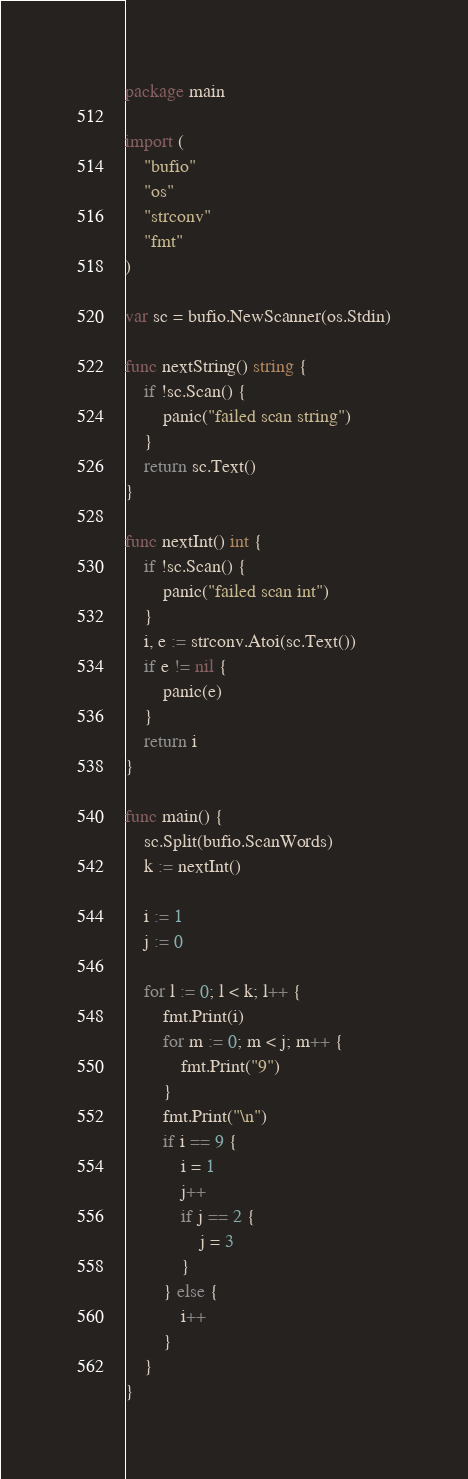<code> <loc_0><loc_0><loc_500><loc_500><_Go_>package main

import (
	"bufio"
	"os"
	"strconv"
	"fmt"
)

var sc = bufio.NewScanner(os.Stdin)

func nextString() string {
	if !sc.Scan() {
		panic("failed scan string")
	}
	return sc.Text()
}

func nextInt() int {
	if !sc.Scan() {
		panic("failed scan int")
	}
	i, e := strconv.Atoi(sc.Text())
	if e != nil {
		panic(e)
	}
	return i
}

func main() {
	sc.Split(bufio.ScanWords)
	k := nextInt()

	i := 1
	j := 0

	for l := 0; l < k; l++ {
		fmt.Print(i)
		for m := 0; m < j; m++ {
			fmt.Print("9")
		}
		fmt.Print("\n")
		if i == 9 {
			i = 1
			j++
			if j == 2 {
				j = 3
			}
		} else {
			i++
		}
	}
}
</code> 